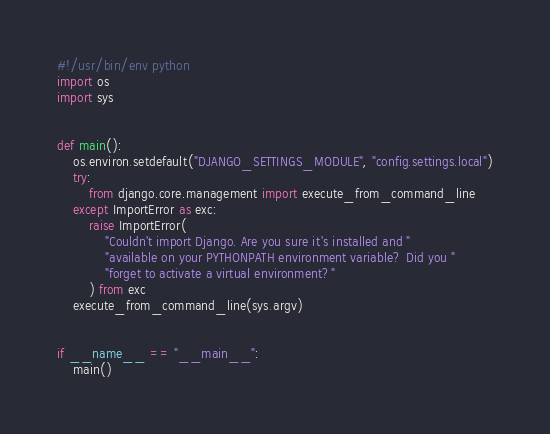<code> <loc_0><loc_0><loc_500><loc_500><_Python_>#!/usr/bin/env python
import os
import sys


def main():
    os.environ.setdefault("DJANGO_SETTINGS_MODULE", "config.settings.local")
    try:
        from django.core.management import execute_from_command_line
    except ImportError as exc:
        raise ImportError(
            "Couldn't import Django. Are you sure it's installed and "
            "available on your PYTHONPATH environment variable? Did you "
            "forget to activate a virtual environment?"
        ) from exc
    execute_from_command_line(sys.argv)


if __name__ == "__main__":
    main()
</code> 